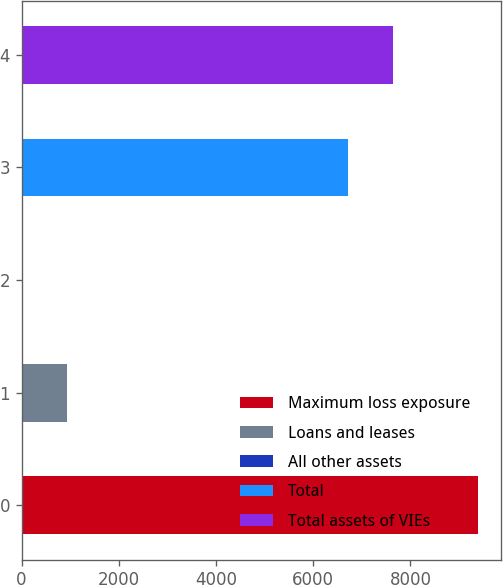Convert chart. <chart><loc_0><loc_0><loc_500><loc_500><bar_chart><fcel>Maximum loss exposure<fcel>Loans and leases<fcel>All other assets<fcel>Total<fcel>Total assets of VIEs<nl><fcel>9388<fcel>942.4<fcel>4<fcel>6713<fcel>7651.4<nl></chart> 